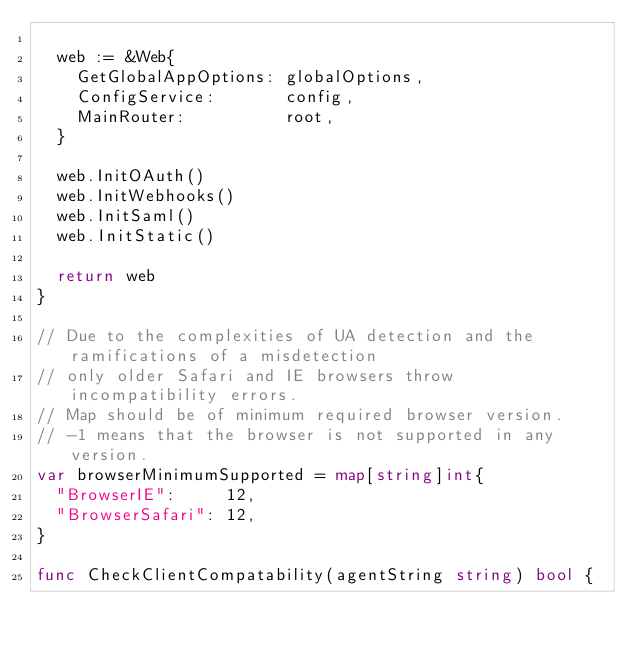Convert code to text. <code><loc_0><loc_0><loc_500><loc_500><_Go_>
	web := &Web{
		GetGlobalAppOptions: globalOptions,
		ConfigService:       config,
		MainRouter:          root,
	}

	web.InitOAuth()
	web.InitWebhooks()
	web.InitSaml()
	web.InitStatic()

	return web
}

// Due to the complexities of UA detection and the ramifications of a misdetection
// only older Safari and IE browsers throw incompatibility errors.
// Map should be of minimum required browser version.
// -1 means that the browser is not supported in any version.
var browserMinimumSupported = map[string]int{
	"BrowserIE":     12,
	"BrowserSafari": 12,
}

func CheckClientCompatability(agentString string) bool {</code> 